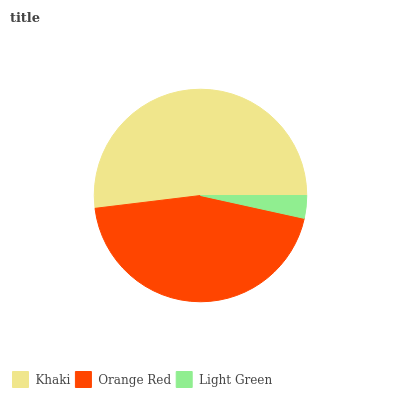Is Light Green the minimum?
Answer yes or no. Yes. Is Khaki the maximum?
Answer yes or no. Yes. Is Orange Red the minimum?
Answer yes or no. No. Is Orange Red the maximum?
Answer yes or no. No. Is Khaki greater than Orange Red?
Answer yes or no. Yes. Is Orange Red less than Khaki?
Answer yes or no. Yes. Is Orange Red greater than Khaki?
Answer yes or no. No. Is Khaki less than Orange Red?
Answer yes or no. No. Is Orange Red the high median?
Answer yes or no. Yes. Is Orange Red the low median?
Answer yes or no. Yes. Is Khaki the high median?
Answer yes or no. No. Is Khaki the low median?
Answer yes or no. No. 